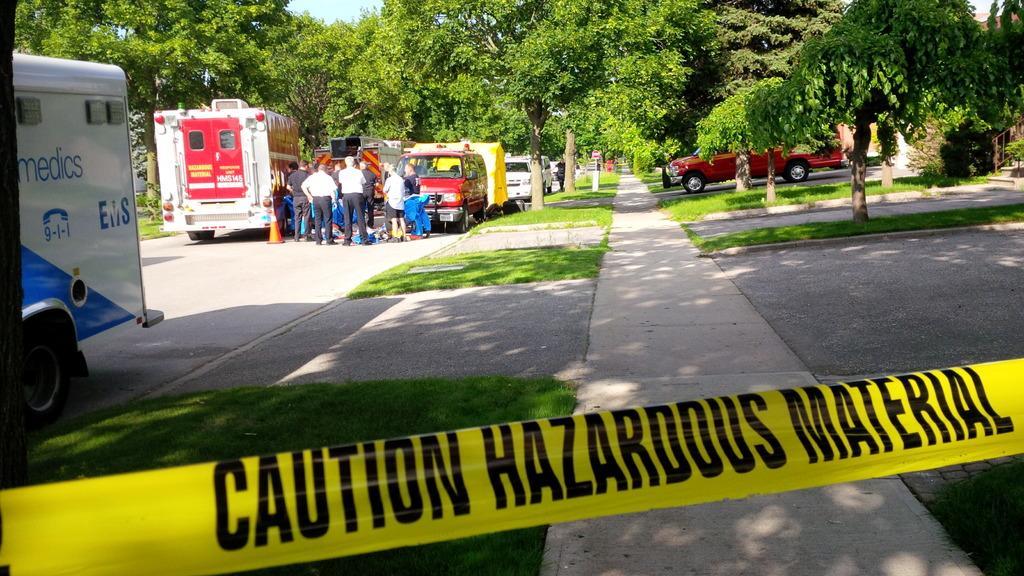Please provide a concise description of this image. In this image we can see different types of vehicles and some persons standing near the vehicles and at the background of the image there are some trees. 